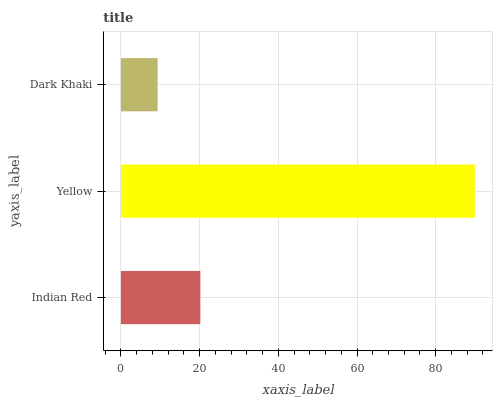Is Dark Khaki the minimum?
Answer yes or no. Yes. Is Yellow the maximum?
Answer yes or no. Yes. Is Yellow the minimum?
Answer yes or no. No. Is Dark Khaki the maximum?
Answer yes or no. No. Is Yellow greater than Dark Khaki?
Answer yes or no. Yes. Is Dark Khaki less than Yellow?
Answer yes or no. Yes. Is Dark Khaki greater than Yellow?
Answer yes or no. No. Is Yellow less than Dark Khaki?
Answer yes or no. No. Is Indian Red the high median?
Answer yes or no. Yes. Is Indian Red the low median?
Answer yes or no. Yes. Is Yellow the high median?
Answer yes or no. No. Is Dark Khaki the low median?
Answer yes or no. No. 